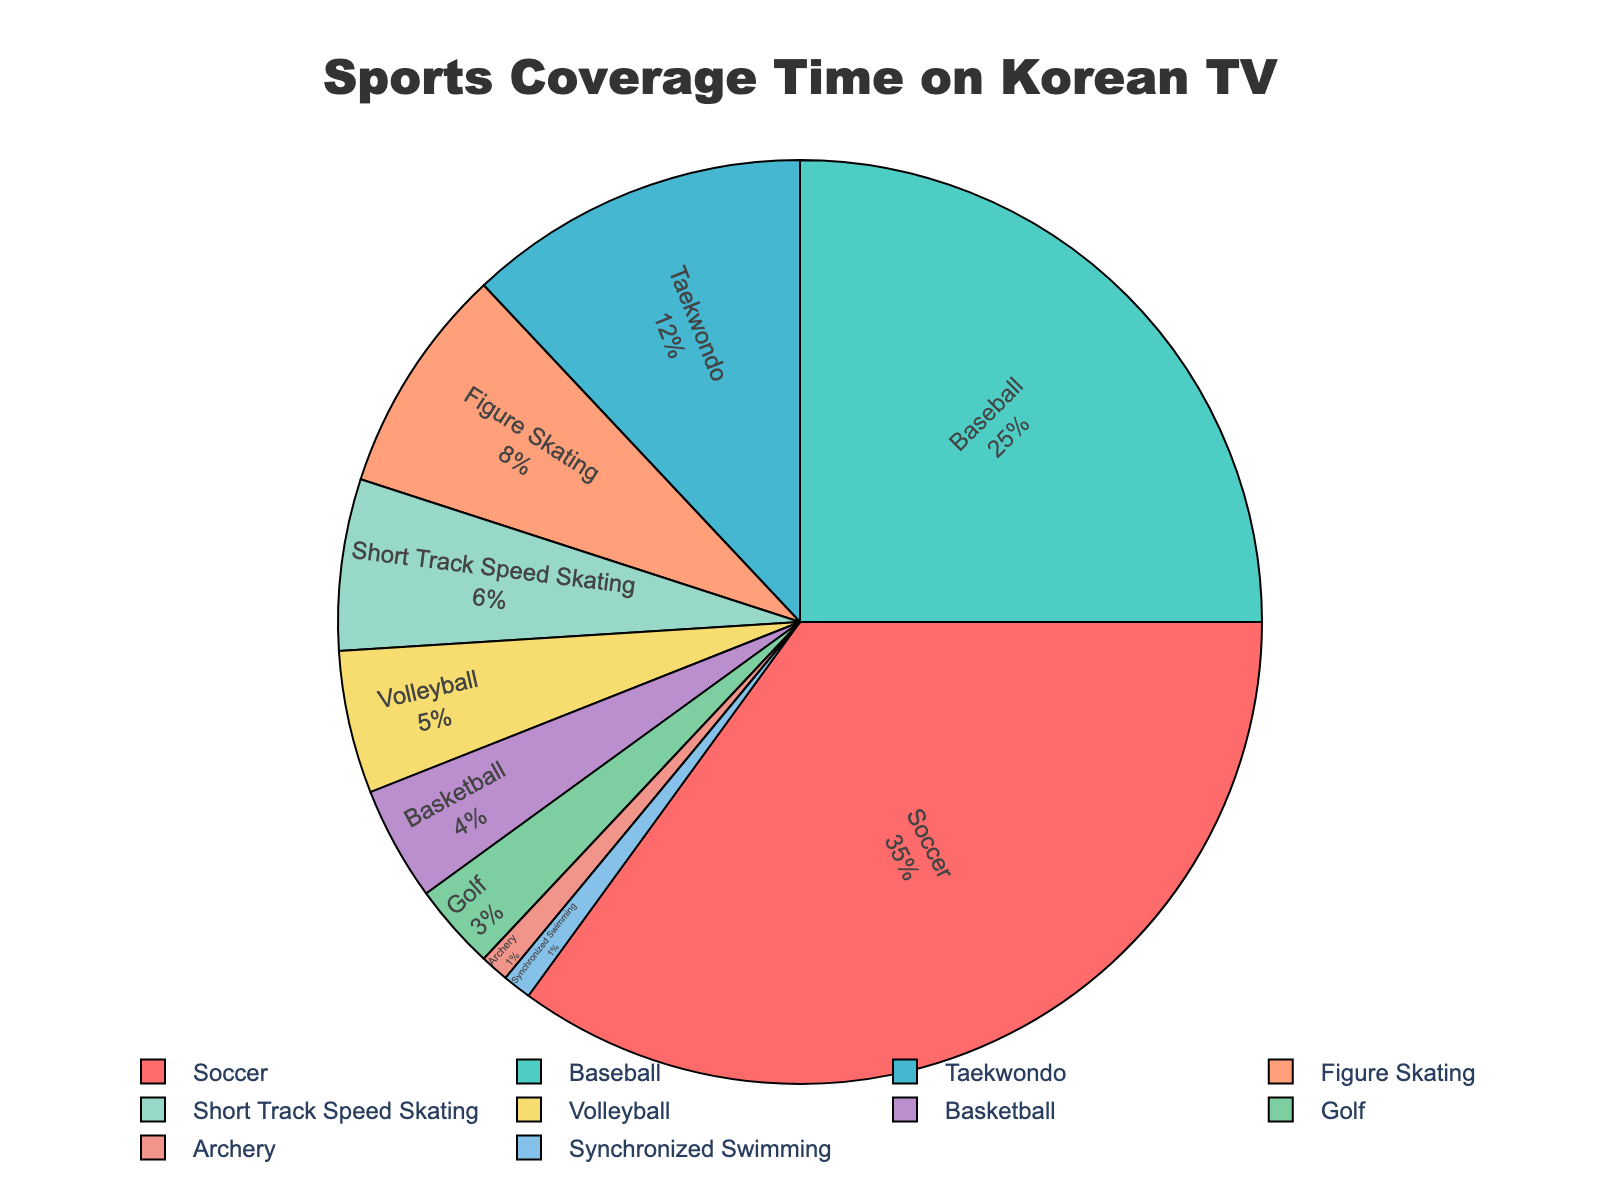which sport has the highest coverage time? The figure shows a pie chart with different sports. The largest section corresponds to Soccer, representing 35% of the coverage time.
Answer: Soccer which sports have the lowest coverage time? From the pie chart, the smallest sections are for Archery and Synchronized Swimming, both representing 1% of the coverage time.
Answer: Archery, Synchronized Swimming how much more coverage time does soccer have than basketball? Soccer has 35% of the coverage time, and Basketball has 4%. The difference is 35% - 4% = 31%.
Answer: 31% which has a higher coverage time, taekwondo or volleyball? By how much? Taekwondo has 12% of the coverage time, and Volleyball has 5%. Taekwondo has a higher coverage time by 12% - 5% = 7%.
Answer: Taekwondo, 7% combine the coverage times of figure skating and short track speed skating. What is the total? Figure Skating has 8%, and Short Track Speed Skating has 6%. The combined coverage time is 8% + 6% = 14%.
Answer: 14% which two sports combined have a total coverage time equal to baseball’s coverage time? Baseball has 25% of the coverage time. Taekwondo and Volleyball combined have 12% + 5% = 17%, and adding Basketball makes it 17% + 4% = 21%, still less. Adding Golf to the previous total of 21% makes 21% + 3% = 24%, nearest to 25% but not exactly.
Answer: None is there any sport that has exactly the same coverage time as synchronized swimming? Yes, the pie chart shows that Archery has the same coverage time as Synchronized Swimming, both are 1%.
Answer: Archery among soccer, baseball, and volleyball, which has the least coverage time, and what's its percentage? Soccer has 35%, Baseball has 25%, and Volleyball has 5%. Volleyball has the least coverage time among them.
Answer: Volleyball, 5% which is the only sport with coverage time under 5% but greater than 3%? The pie chart shows that Basketball has 4% coverage time, which fits this criteria.
Answer: Basketball what is the combined percentage of all sports except soccer? The coverage time excluding Soccer is Baseball 25% + Taekwondo 12% + Figure Skating 8% + Short Track Speed Skating 6% + Volleyball 5% + Basketball 4% + Golf 3% + Archery 1% + Synchronized Swimming 1%. Adding these gives 25% + 12% + 8% + 6% + 5% + 4% + 3% + 1% + 1% = 65%.
Answer: 65% 